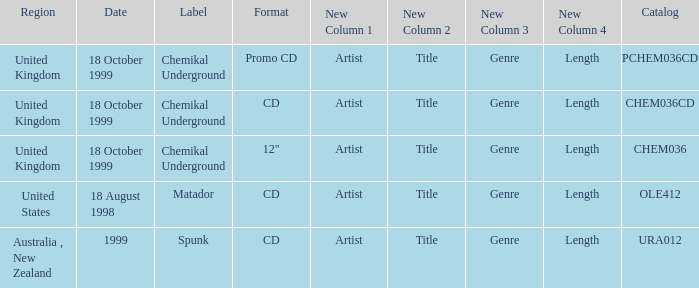What date is associated with the Spunk label? 1999.0. 